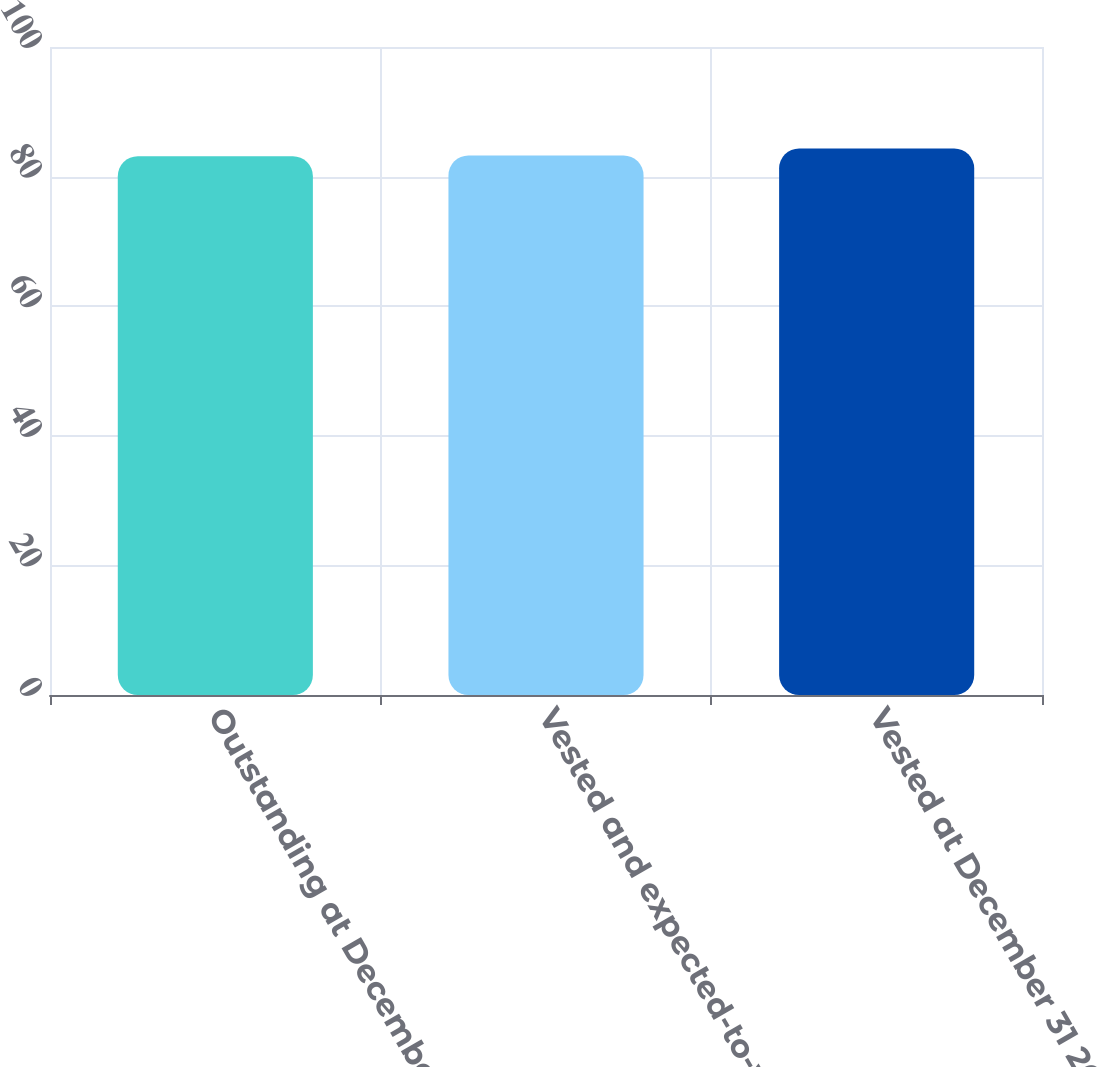Convert chart to OTSL. <chart><loc_0><loc_0><loc_500><loc_500><bar_chart><fcel>Outstanding at December 31<fcel>Vested and expected-to-vest at<fcel>Vested at December 31 2012<nl><fcel>83.15<fcel>83.27<fcel>84.35<nl></chart> 